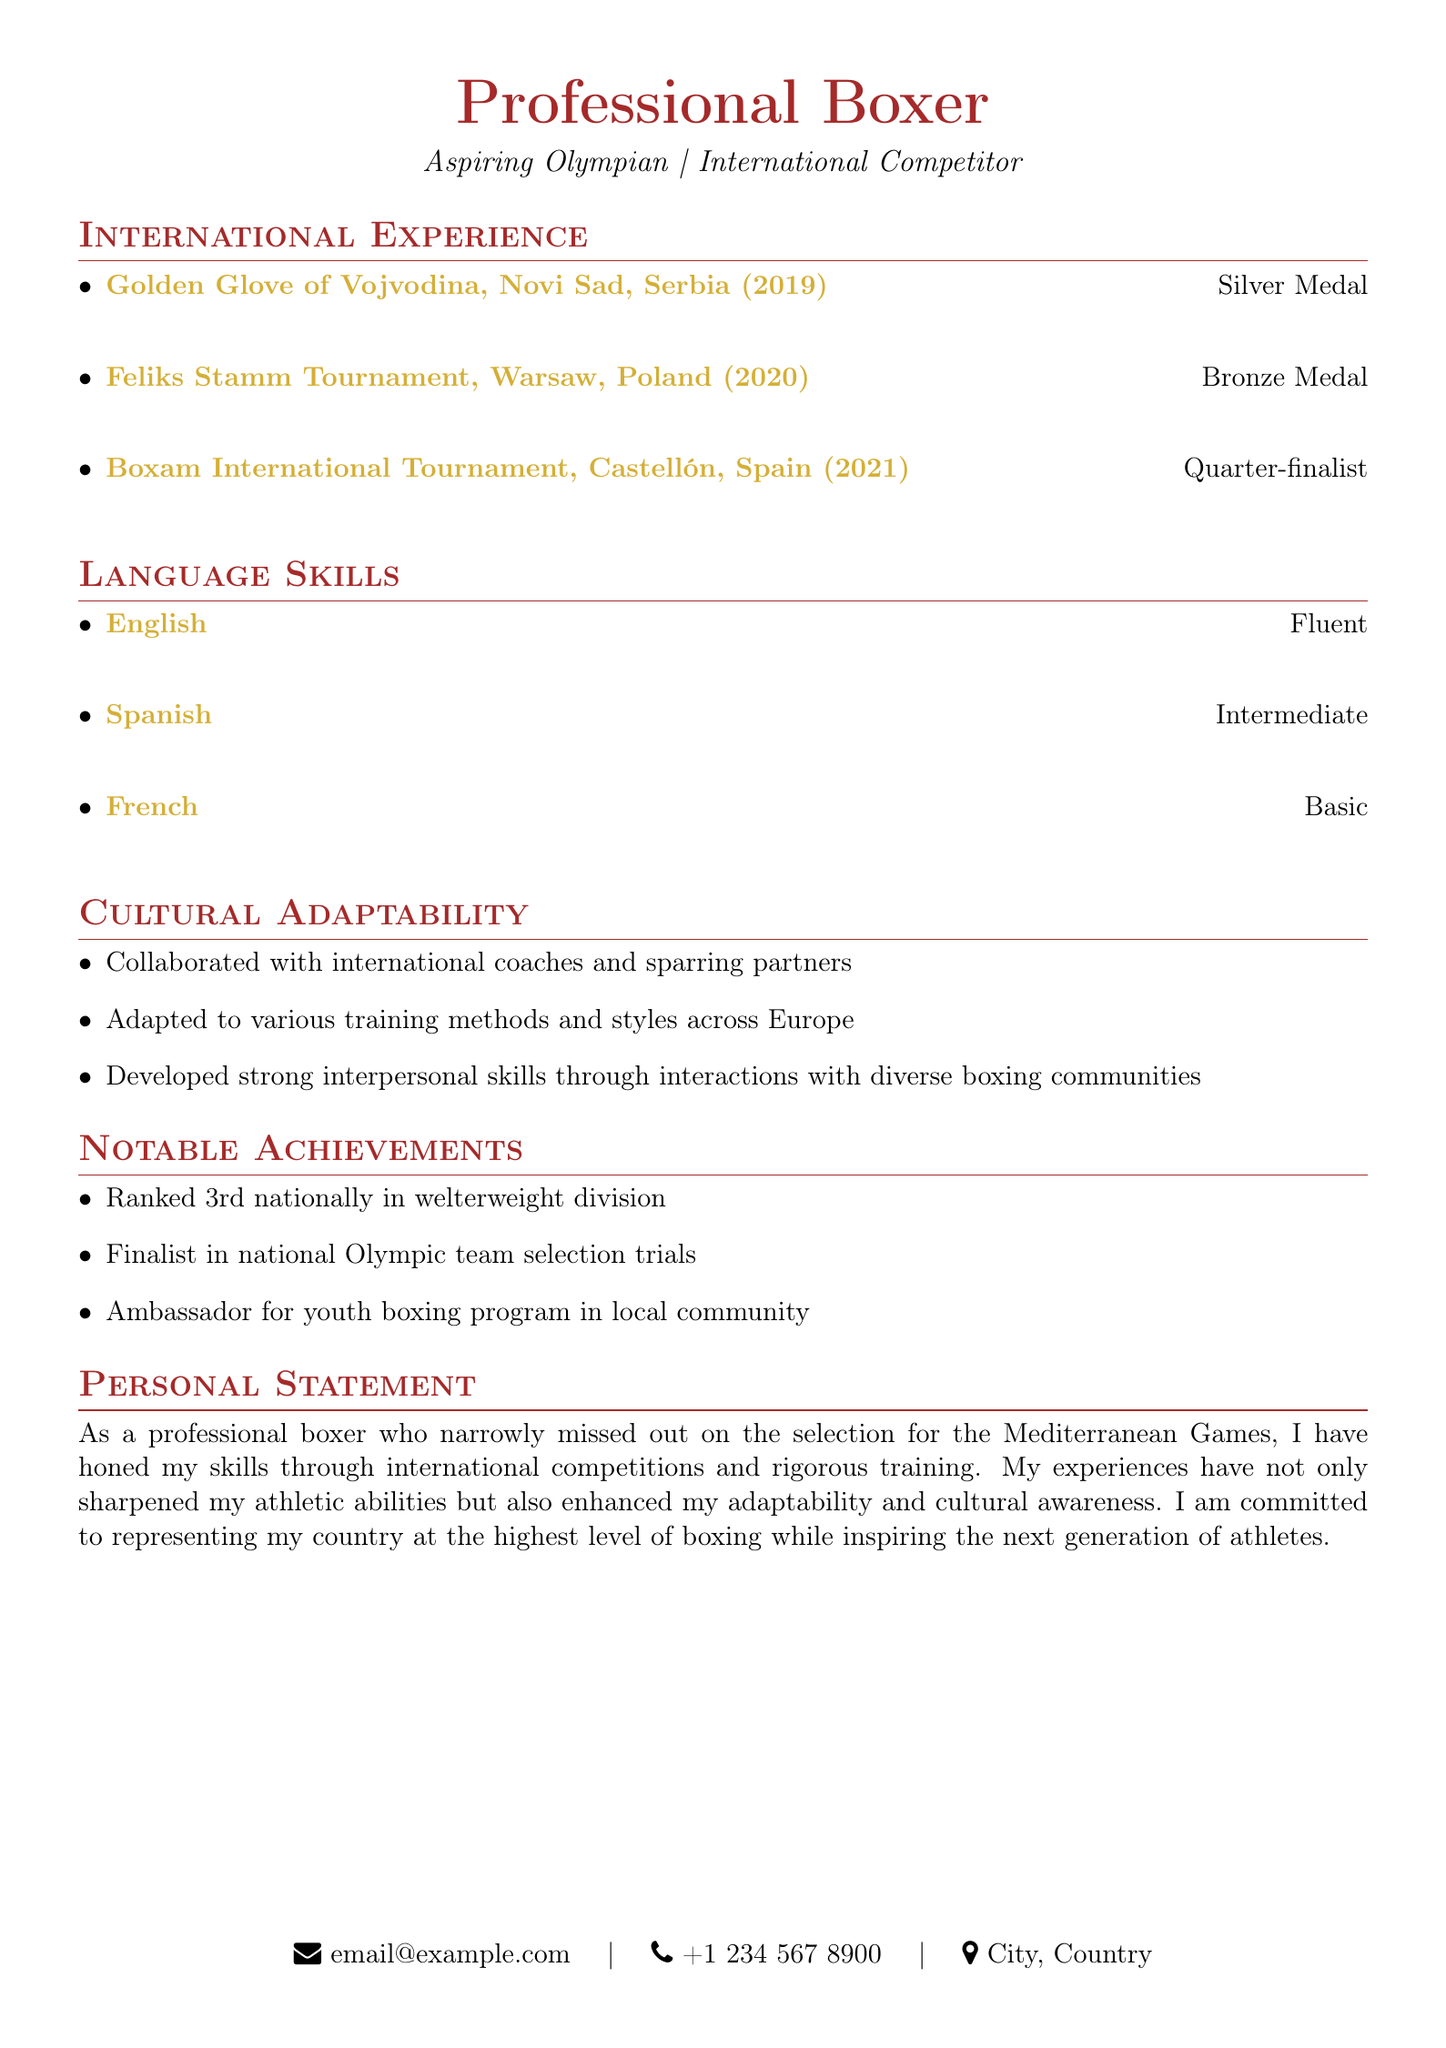what medal was achieved at the Golden Glove of Vojvodina? The document states that a Silver Medal was achieved at the Golden Glove of Vojvodina.
Answer: Silver Medal in which country did the Feliks Stamm Tournament take place? The document specifies that the Feliks Stamm Tournament took place in Warsaw, Poland.
Answer: Poland what is the proficiency level in Spanish? The document indicates that the proficiency level in Spanish is Intermediate.
Answer: Intermediate how many international boxing experiences are listed in the document? The document lists three international boxing experiences.
Answer: 3 which tournament resulted in a quarter-finalist achievement? According to the document, the Boxam International Tournament resulted in a quarter-finalist achievement.
Answer: Boxam International Tournament what cultural skill was developed through interactions with diverse boxing communities? The document mentions that strong interpersonal skills were developed through interactions with diverse boxing communities.
Answer: Interpersonal skills who is the ambassador for the youth boxing program? The document states that the individual presenting this CV is the ambassador for the youth boxing program.
Answer: The individual what is the highest rank achieved in the national welterweight division? The document indicates that the highest rank achieved in the national welterweight division is 3rd.
Answer: 3rd what year was the Boxam International Tournament held? The document states that the Boxam International Tournament was held in 2021.
Answer: 2021 